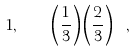Convert formula to latex. <formula><loc_0><loc_0><loc_500><loc_500>1 , \quad \left ( \frac { 1 } { 3 } \right ) \left ( \frac { 2 } { 3 } \right ) \ ,</formula> 